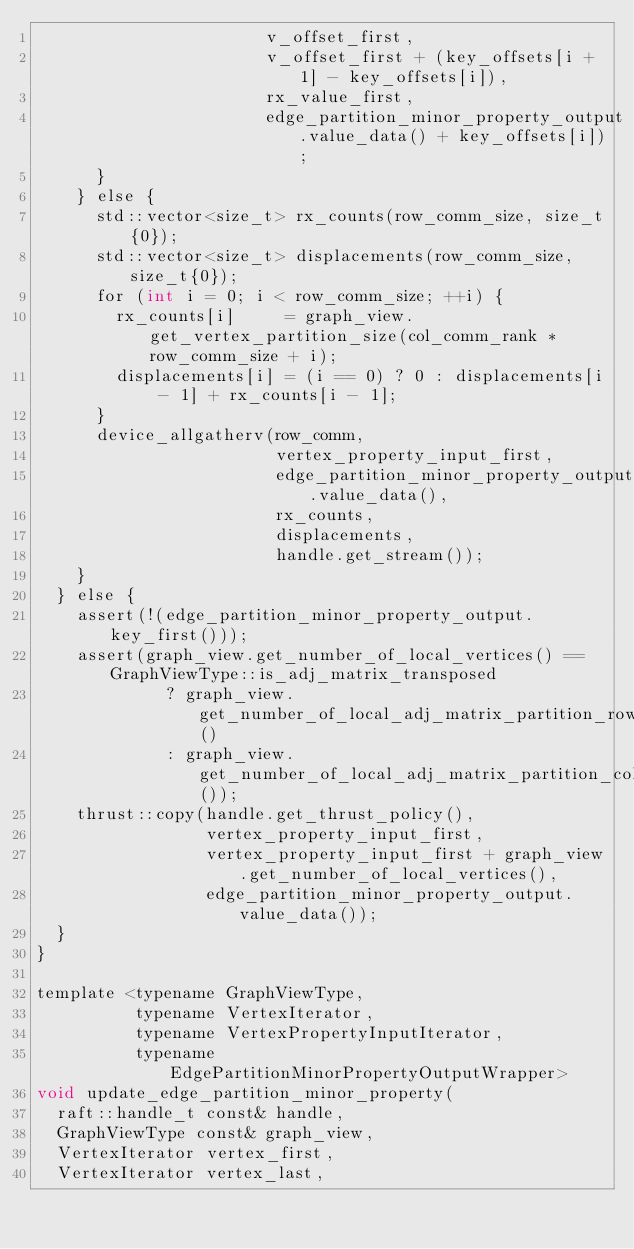<code> <loc_0><loc_0><loc_500><loc_500><_Cuda_>                       v_offset_first,
                       v_offset_first + (key_offsets[i + 1] - key_offsets[i]),
                       rx_value_first,
                       edge_partition_minor_property_output.value_data() + key_offsets[i]);
      }
    } else {
      std::vector<size_t> rx_counts(row_comm_size, size_t{0});
      std::vector<size_t> displacements(row_comm_size, size_t{0});
      for (int i = 0; i < row_comm_size; ++i) {
        rx_counts[i]     = graph_view.get_vertex_partition_size(col_comm_rank * row_comm_size + i);
        displacements[i] = (i == 0) ? 0 : displacements[i - 1] + rx_counts[i - 1];
      }
      device_allgatherv(row_comm,
                        vertex_property_input_first,
                        edge_partition_minor_property_output.value_data(),
                        rx_counts,
                        displacements,
                        handle.get_stream());
    }
  } else {
    assert(!(edge_partition_minor_property_output.key_first()));
    assert(graph_view.get_number_of_local_vertices() == GraphViewType::is_adj_matrix_transposed
             ? graph_view.get_number_of_local_adj_matrix_partition_rows()
             : graph_view.get_number_of_local_adj_matrix_partition_cols());
    thrust::copy(handle.get_thrust_policy(),
                 vertex_property_input_first,
                 vertex_property_input_first + graph_view.get_number_of_local_vertices(),
                 edge_partition_minor_property_output.value_data());
  }
}

template <typename GraphViewType,
          typename VertexIterator,
          typename VertexPropertyInputIterator,
          typename EdgePartitionMinorPropertyOutputWrapper>
void update_edge_partition_minor_property(
  raft::handle_t const& handle,
  GraphViewType const& graph_view,
  VertexIterator vertex_first,
  VertexIterator vertex_last,</code> 